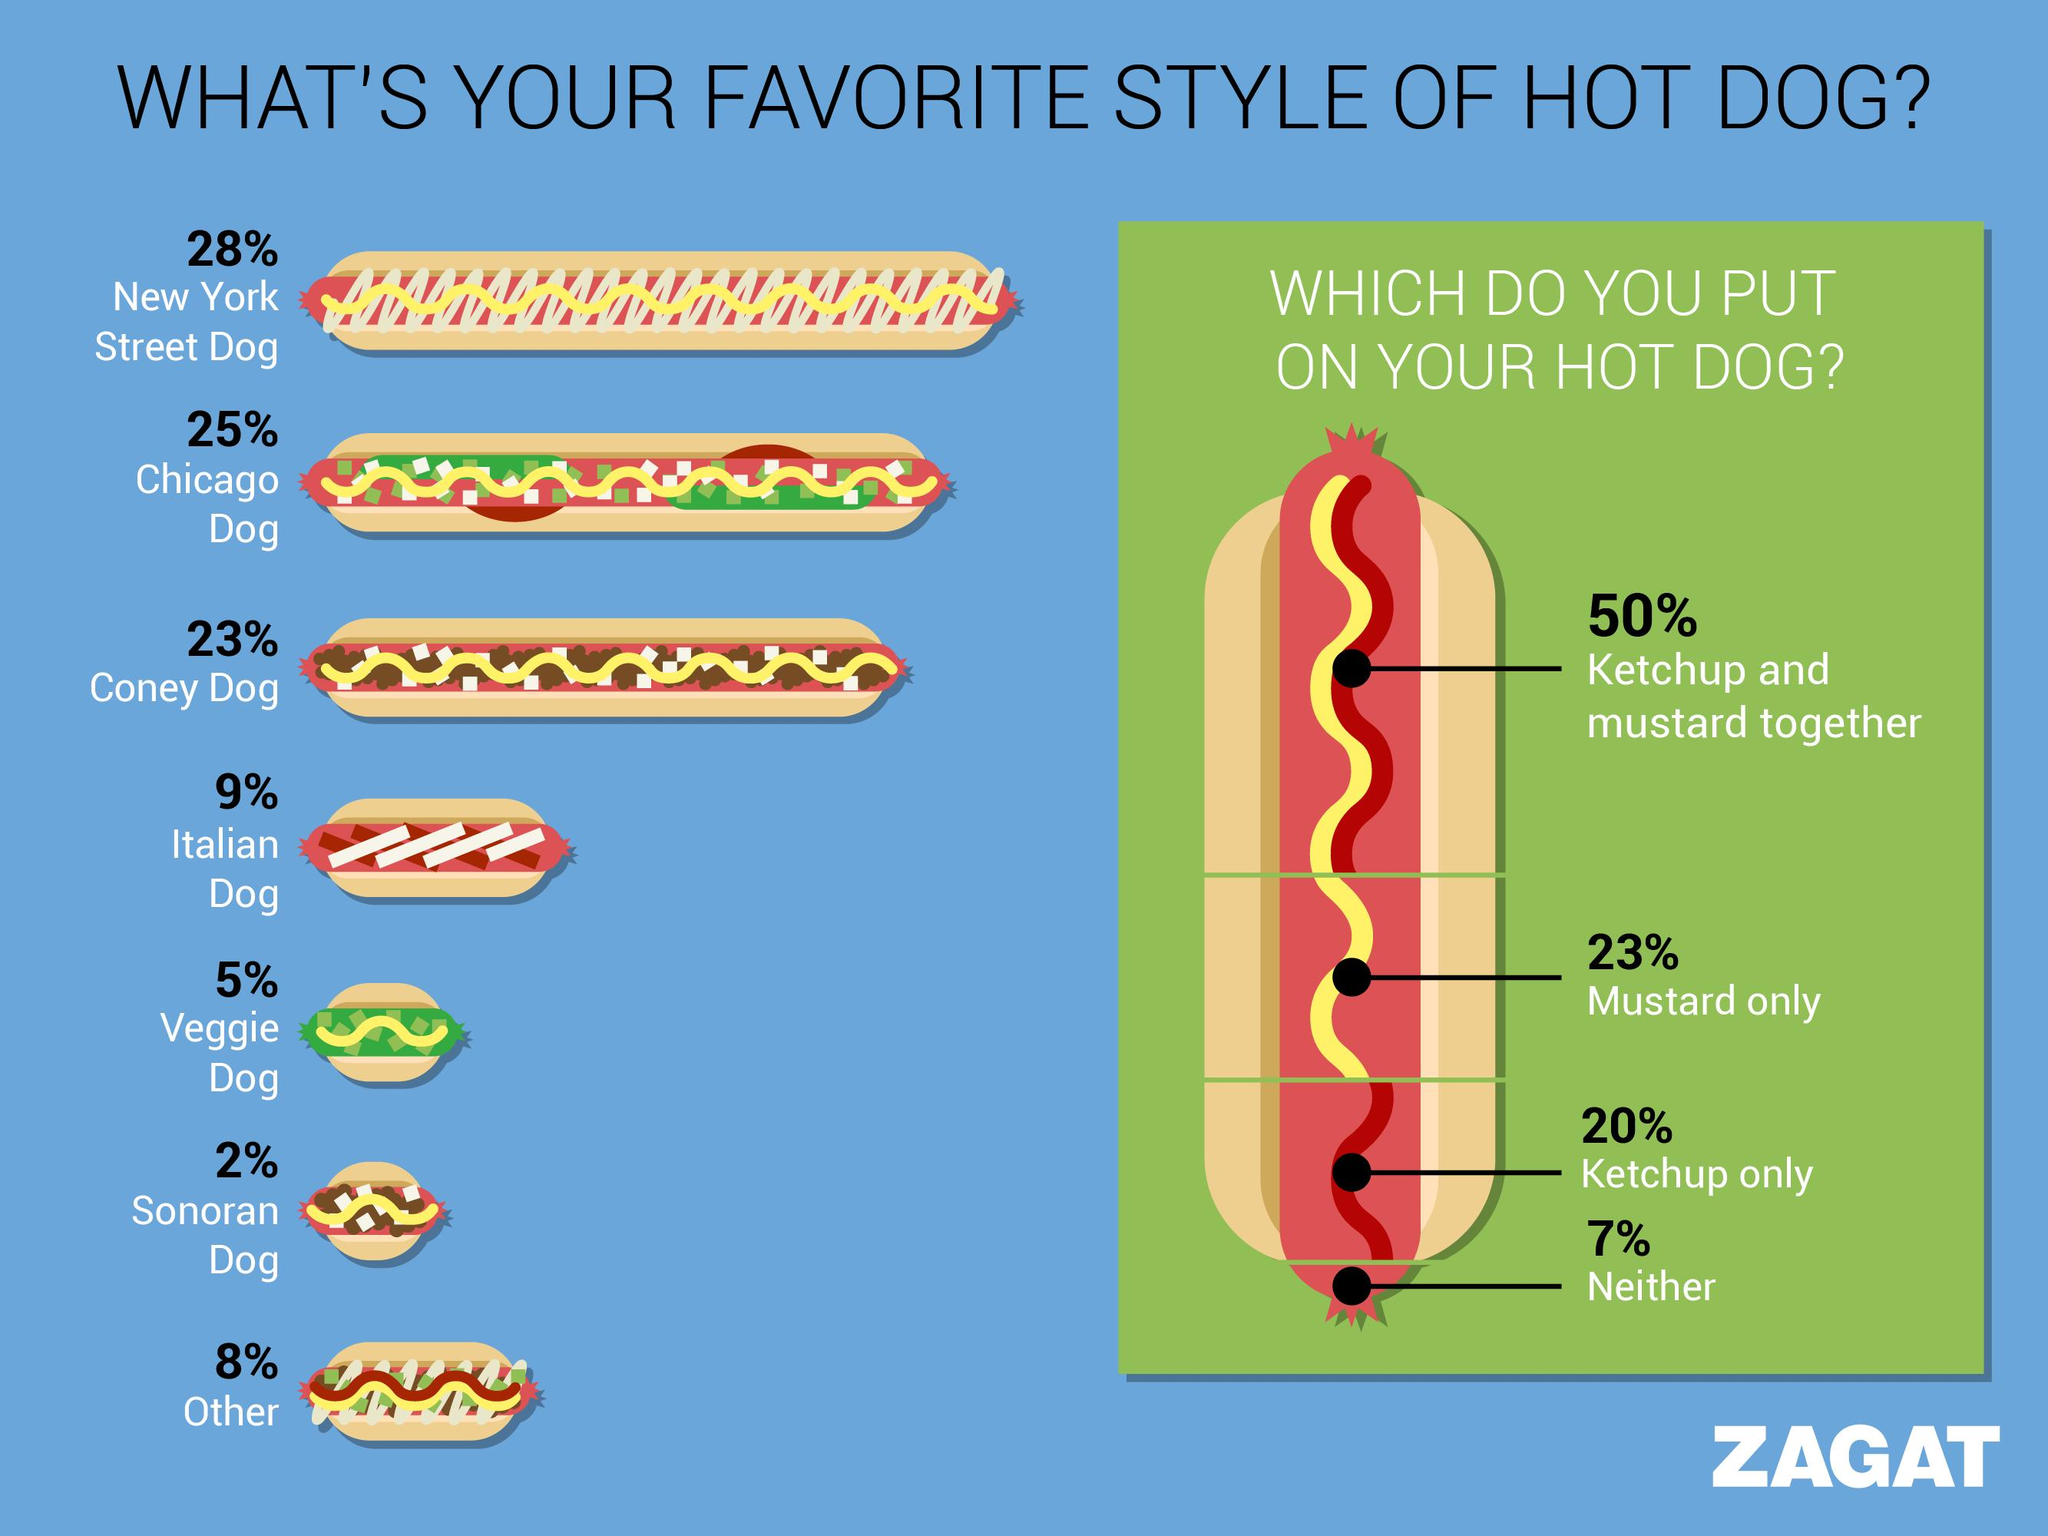Give some essential details in this illustration. According to the survey, the dressing that is most preferred by people is a combination of ketchup and mustard. The other options, either mustard only or ketchup only, were less popular among respondents. According to a survey, 7% of people do not want any dressing on their salads. There are two dressings or sauces. According to a survey, 48% of people surveyed stated that they enjoy both Chicago-style hot dogs and Coney dogs. 